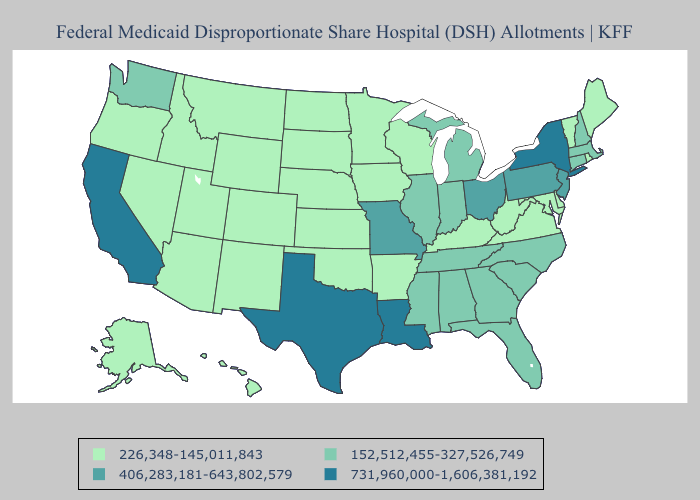Does the map have missing data?
Be succinct. No. Name the states that have a value in the range 731,960,000-1,606,381,192?
Keep it brief. California, Louisiana, New York, Texas. Does Vermont have the lowest value in the Northeast?
Give a very brief answer. Yes. Does West Virginia have the highest value in the USA?
Quick response, please. No. What is the highest value in the South ?
Give a very brief answer. 731,960,000-1,606,381,192. Does Georgia have the lowest value in the USA?
Be succinct. No. What is the value of Pennsylvania?
Answer briefly. 406,283,181-643,802,579. Name the states that have a value in the range 226,348-145,011,843?
Quick response, please. Alaska, Arizona, Arkansas, Colorado, Delaware, Hawaii, Idaho, Iowa, Kansas, Kentucky, Maine, Maryland, Minnesota, Montana, Nebraska, Nevada, New Mexico, North Dakota, Oklahoma, Oregon, Rhode Island, South Dakota, Utah, Vermont, Virginia, West Virginia, Wisconsin, Wyoming. Name the states that have a value in the range 226,348-145,011,843?
Quick response, please. Alaska, Arizona, Arkansas, Colorado, Delaware, Hawaii, Idaho, Iowa, Kansas, Kentucky, Maine, Maryland, Minnesota, Montana, Nebraska, Nevada, New Mexico, North Dakota, Oklahoma, Oregon, Rhode Island, South Dakota, Utah, Vermont, Virginia, West Virginia, Wisconsin, Wyoming. Among the states that border Tennessee , which have the highest value?
Write a very short answer. Missouri. Does Washington have a lower value than Kentucky?
Concise answer only. No. Among the states that border Kansas , does Missouri have the highest value?
Keep it brief. Yes. Does Iowa have the same value as New York?
Quick response, please. No. What is the highest value in states that border South Carolina?
Concise answer only. 152,512,455-327,526,749. What is the lowest value in the USA?
Concise answer only. 226,348-145,011,843. 